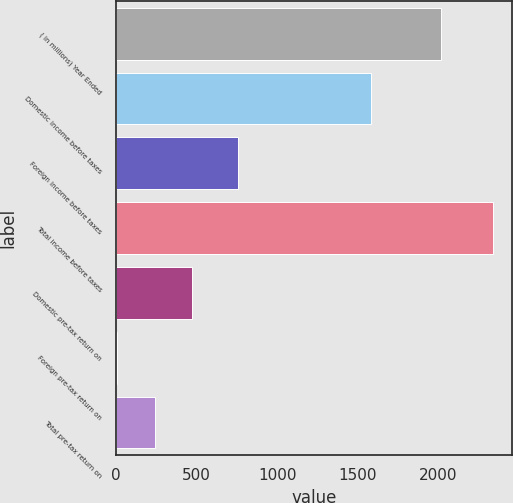Convert chart. <chart><loc_0><loc_0><loc_500><loc_500><bar_chart><fcel>( in millions) Year Ended<fcel>Domestic income before taxes<fcel>Foreign income before taxes<fcel>Total income before taxes<fcel>Domestic pre-tax return on<fcel>Foreign pre-tax return on<fcel>Total pre-tax return on<nl><fcel>2015<fcel>1581.6<fcel>755.5<fcel>2337.1<fcel>475.34<fcel>9.9<fcel>242.62<nl></chart> 